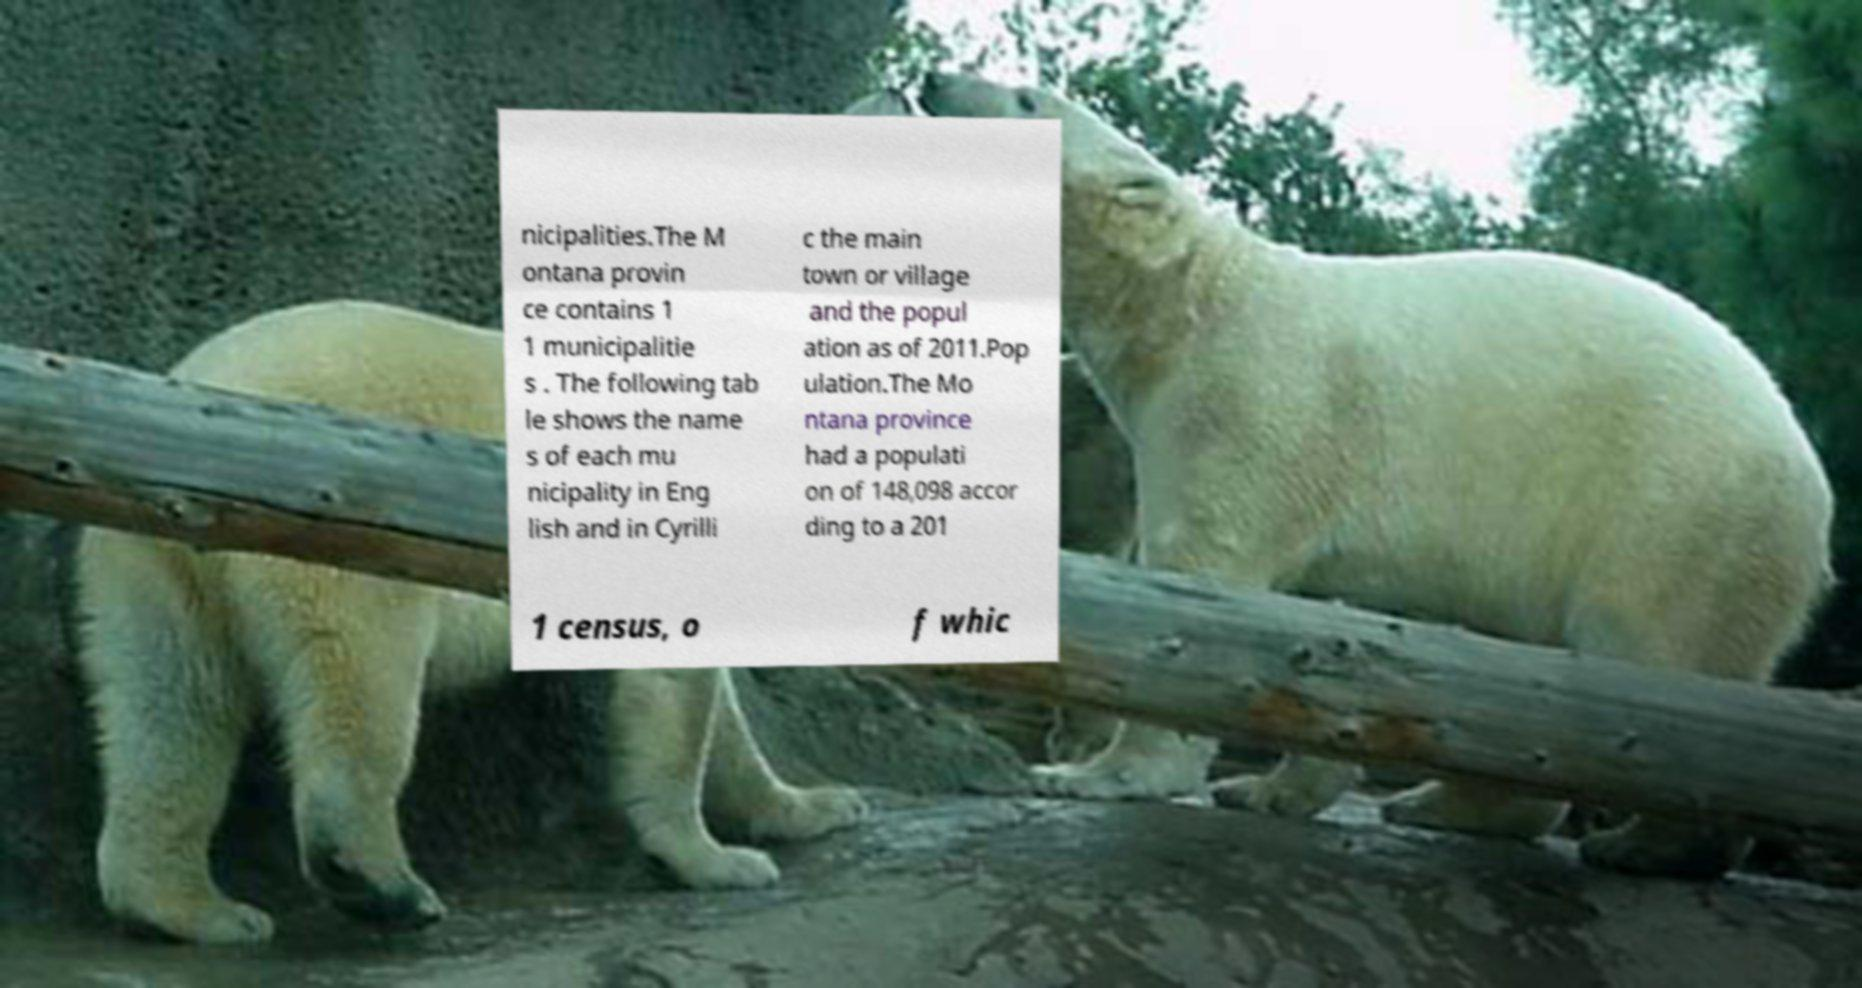I need the written content from this picture converted into text. Can you do that? nicipalities.The M ontana provin ce contains 1 1 municipalitie s . The following tab le shows the name s of each mu nicipality in Eng lish and in Cyrilli c the main town or village and the popul ation as of 2011.Pop ulation.The Mo ntana province had a populati on of 148,098 accor ding to a 201 1 census, o f whic 